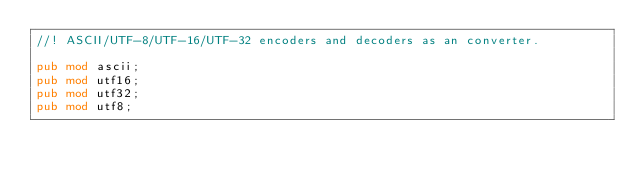<code> <loc_0><loc_0><loc_500><loc_500><_Rust_>//! ASCII/UTF-8/UTF-16/UTF-32 encoders and decoders as an converter.

pub mod ascii;
pub mod utf16;
pub mod utf32;
pub mod utf8;
</code> 